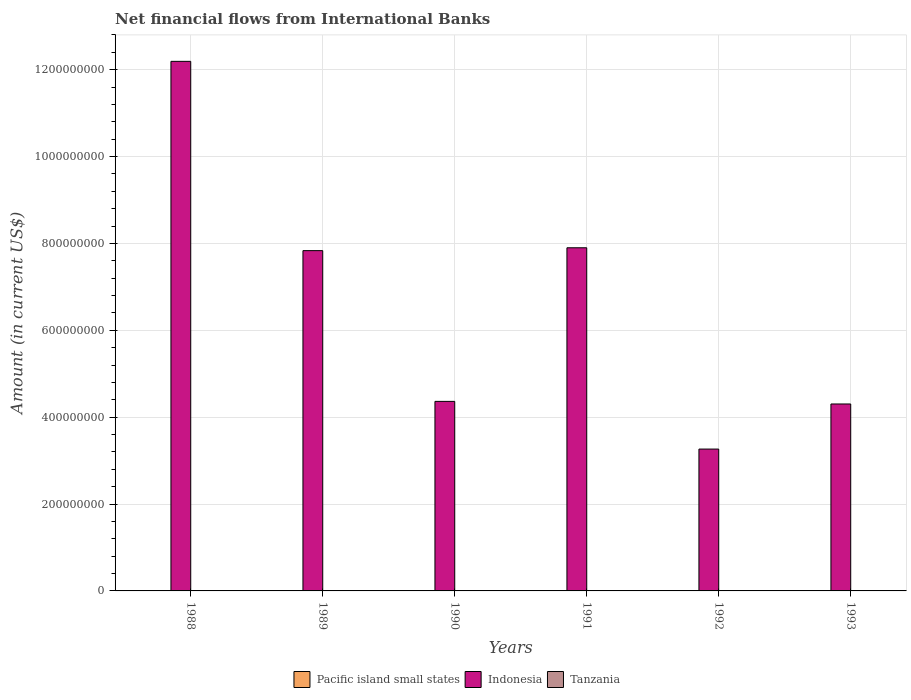How many different coloured bars are there?
Provide a succinct answer. 1. Are the number of bars per tick equal to the number of legend labels?
Make the answer very short. No. How many bars are there on the 3rd tick from the left?
Offer a terse response. 1. How many bars are there on the 1st tick from the right?
Make the answer very short. 1. What is the net financial aid flows in Indonesia in 1991?
Offer a terse response. 7.90e+08. Across all years, what is the maximum net financial aid flows in Indonesia?
Ensure brevity in your answer.  1.22e+09. In which year was the net financial aid flows in Indonesia maximum?
Ensure brevity in your answer.  1988. What is the total net financial aid flows in Indonesia in the graph?
Make the answer very short. 3.99e+09. What is the difference between the net financial aid flows in Indonesia in 1990 and that in 1992?
Your response must be concise. 1.10e+08. What is the difference between the net financial aid flows in Indonesia in 1992 and the net financial aid flows in Tanzania in 1990?
Provide a succinct answer. 3.27e+08. In how many years, is the net financial aid flows in Pacific island small states greater than 1160000000 US$?
Provide a succinct answer. 0. What is the ratio of the net financial aid flows in Indonesia in 1988 to that in 1991?
Offer a very short reply. 1.54. What is the difference between the highest and the second highest net financial aid flows in Indonesia?
Ensure brevity in your answer.  4.29e+08. What is the difference between the highest and the lowest net financial aid flows in Indonesia?
Make the answer very short. 8.93e+08. In how many years, is the net financial aid flows in Indonesia greater than the average net financial aid flows in Indonesia taken over all years?
Make the answer very short. 3. Is the sum of the net financial aid flows in Indonesia in 1988 and 1991 greater than the maximum net financial aid flows in Tanzania across all years?
Your response must be concise. Yes. How many bars are there?
Keep it short and to the point. 6. How many years are there in the graph?
Provide a succinct answer. 6. What is the difference between two consecutive major ticks on the Y-axis?
Offer a very short reply. 2.00e+08. Are the values on the major ticks of Y-axis written in scientific E-notation?
Provide a succinct answer. No. Does the graph contain any zero values?
Your answer should be very brief. Yes. Where does the legend appear in the graph?
Provide a succinct answer. Bottom center. How many legend labels are there?
Provide a short and direct response. 3. What is the title of the graph?
Your response must be concise. Net financial flows from International Banks. Does "Grenada" appear as one of the legend labels in the graph?
Your answer should be compact. No. What is the label or title of the X-axis?
Offer a very short reply. Years. What is the Amount (in current US$) in Indonesia in 1988?
Provide a succinct answer. 1.22e+09. What is the Amount (in current US$) in Pacific island small states in 1989?
Your answer should be compact. 0. What is the Amount (in current US$) of Indonesia in 1989?
Provide a succinct answer. 7.83e+08. What is the Amount (in current US$) in Tanzania in 1989?
Offer a terse response. 0. What is the Amount (in current US$) of Pacific island small states in 1990?
Keep it short and to the point. 0. What is the Amount (in current US$) of Indonesia in 1990?
Give a very brief answer. 4.36e+08. What is the Amount (in current US$) of Pacific island small states in 1991?
Provide a succinct answer. 0. What is the Amount (in current US$) of Indonesia in 1991?
Give a very brief answer. 7.90e+08. What is the Amount (in current US$) in Indonesia in 1992?
Ensure brevity in your answer.  3.27e+08. What is the Amount (in current US$) of Pacific island small states in 1993?
Ensure brevity in your answer.  0. What is the Amount (in current US$) in Indonesia in 1993?
Offer a very short reply. 4.30e+08. What is the Amount (in current US$) of Tanzania in 1993?
Keep it short and to the point. 0. Across all years, what is the maximum Amount (in current US$) of Indonesia?
Give a very brief answer. 1.22e+09. Across all years, what is the minimum Amount (in current US$) of Indonesia?
Offer a terse response. 3.27e+08. What is the total Amount (in current US$) of Pacific island small states in the graph?
Provide a short and direct response. 0. What is the total Amount (in current US$) in Indonesia in the graph?
Ensure brevity in your answer.  3.99e+09. What is the total Amount (in current US$) in Tanzania in the graph?
Ensure brevity in your answer.  0. What is the difference between the Amount (in current US$) in Indonesia in 1988 and that in 1989?
Provide a succinct answer. 4.36e+08. What is the difference between the Amount (in current US$) of Indonesia in 1988 and that in 1990?
Ensure brevity in your answer.  7.83e+08. What is the difference between the Amount (in current US$) in Indonesia in 1988 and that in 1991?
Offer a very short reply. 4.29e+08. What is the difference between the Amount (in current US$) of Indonesia in 1988 and that in 1992?
Offer a very short reply. 8.93e+08. What is the difference between the Amount (in current US$) in Indonesia in 1988 and that in 1993?
Make the answer very short. 7.89e+08. What is the difference between the Amount (in current US$) of Indonesia in 1989 and that in 1990?
Your response must be concise. 3.47e+08. What is the difference between the Amount (in current US$) of Indonesia in 1989 and that in 1991?
Your answer should be very brief. -6.59e+06. What is the difference between the Amount (in current US$) of Indonesia in 1989 and that in 1992?
Offer a terse response. 4.57e+08. What is the difference between the Amount (in current US$) of Indonesia in 1989 and that in 1993?
Your answer should be very brief. 3.53e+08. What is the difference between the Amount (in current US$) in Indonesia in 1990 and that in 1991?
Give a very brief answer. -3.54e+08. What is the difference between the Amount (in current US$) of Indonesia in 1990 and that in 1992?
Offer a very short reply. 1.10e+08. What is the difference between the Amount (in current US$) of Indonesia in 1990 and that in 1993?
Provide a succinct answer. 5.98e+06. What is the difference between the Amount (in current US$) in Indonesia in 1991 and that in 1992?
Provide a short and direct response. 4.63e+08. What is the difference between the Amount (in current US$) of Indonesia in 1991 and that in 1993?
Your answer should be compact. 3.60e+08. What is the difference between the Amount (in current US$) in Indonesia in 1992 and that in 1993?
Make the answer very short. -1.04e+08. What is the average Amount (in current US$) of Indonesia per year?
Your answer should be compact. 6.64e+08. What is the average Amount (in current US$) of Tanzania per year?
Provide a succinct answer. 0. What is the ratio of the Amount (in current US$) in Indonesia in 1988 to that in 1989?
Your response must be concise. 1.56. What is the ratio of the Amount (in current US$) in Indonesia in 1988 to that in 1990?
Make the answer very short. 2.79. What is the ratio of the Amount (in current US$) of Indonesia in 1988 to that in 1991?
Provide a succinct answer. 1.54. What is the ratio of the Amount (in current US$) in Indonesia in 1988 to that in 1992?
Provide a short and direct response. 3.73. What is the ratio of the Amount (in current US$) of Indonesia in 1988 to that in 1993?
Keep it short and to the point. 2.83. What is the ratio of the Amount (in current US$) in Indonesia in 1989 to that in 1990?
Provide a short and direct response. 1.8. What is the ratio of the Amount (in current US$) of Indonesia in 1989 to that in 1991?
Provide a succinct answer. 0.99. What is the ratio of the Amount (in current US$) of Indonesia in 1989 to that in 1992?
Ensure brevity in your answer.  2.4. What is the ratio of the Amount (in current US$) in Indonesia in 1989 to that in 1993?
Make the answer very short. 1.82. What is the ratio of the Amount (in current US$) of Indonesia in 1990 to that in 1991?
Keep it short and to the point. 0.55. What is the ratio of the Amount (in current US$) in Indonesia in 1990 to that in 1992?
Your answer should be compact. 1.34. What is the ratio of the Amount (in current US$) in Indonesia in 1990 to that in 1993?
Make the answer very short. 1.01. What is the ratio of the Amount (in current US$) in Indonesia in 1991 to that in 1992?
Your response must be concise. 2.42. What is the ratio of the Amount (in current US$) of Indonesia in 1991 to that in 1993?
Keep it short and to the point. 1.84. What is the ratio of the Amount (in current US$) of Indonesia in 1992 to that in 1993?
Make the answer very short. 0.76. What is the difference between the highest and the second highest Amount (in current US$) in Indonesia?
Make the answer very short. 4.29e+08. What is the difference between the highest and the lowest Amount (in current US$) of Indonesia?
Your response must be concise. 8.93e+08. 